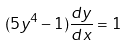<formula> <loc_0><loc_0><loc_500><loc_500>( 5 y ^ { 4 } - 1 ) \frac { d y } { d x } = 1</formula> 